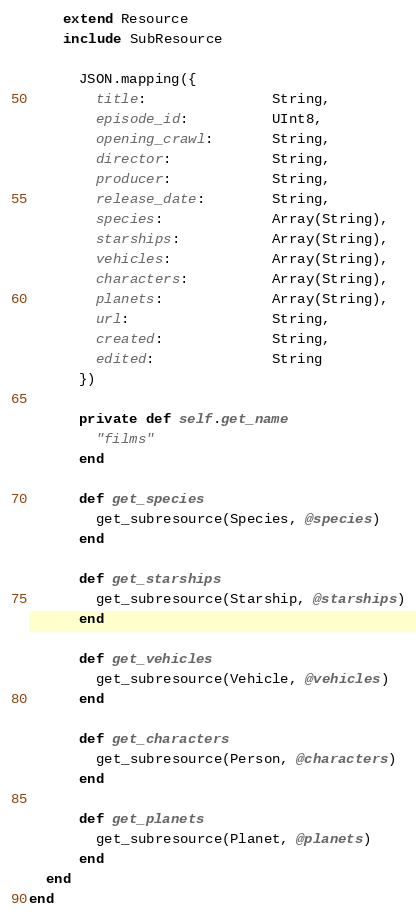<code> <loc_0><loc_0><loc_500><loc_500><_Crystal_>    extend Resource
    include SubResource

      JSON.mapping({
        title:               String,
        episode_id:          UInt8,
        opening_crawl:       String,
        director:            String,
        producer:            String,
        release_date:        String,
        species:             Array(String),
        starships:           Array(String),
        vehicles:            Array(String),
        characters:          Array(String),
        planets:             Array(String),
        url:                 String,
        created:             String,
        edited:              String
      })

      private def self.get_name
        "films"
      end

      def get_species
        get_subresource(Species, @species)
      end

      def get_starships
        get_subresource(Starship, @starships)
      end

      def get_vehicles
        get_subresource(Vehicle, @vehicles)
      end

      def get_characters
        get_subresource(Person, @characters)
      end

      def get_planets
        get_subresource(Planet, @planets)
      end
  end
end</code> 